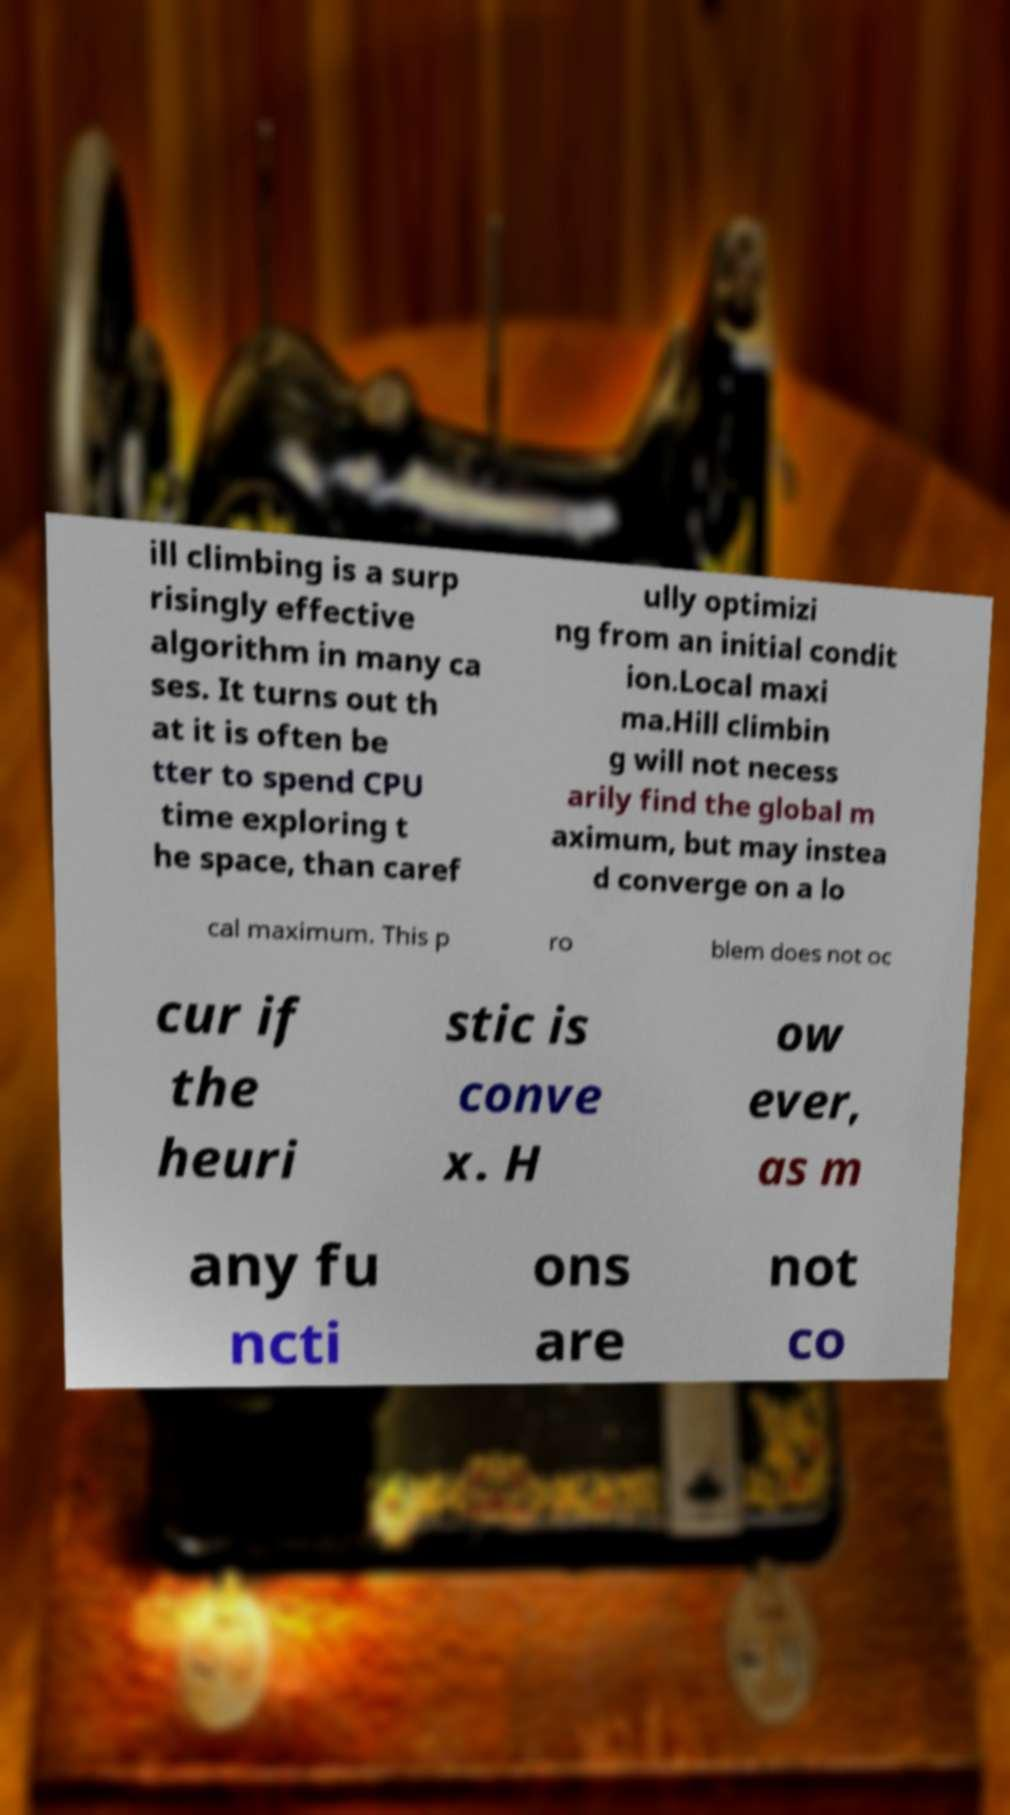I need the written content from this picture converted into text. Can you do that? ill climbing is a surp risingly effective algorithm in many ca ses. It turns out th at it is often be tter to spend CPU time exploring t he space, than caref ully optimizi ng from an initial condit ion.Local maxi ma.Hill climbin g will not necess arily find the global m aximum, but may instea d converge on a lo cal maximum. This p ro blem does not oc cur if the heuri stic is conve x. H ow ever, as m any fu ncti ons are not co 